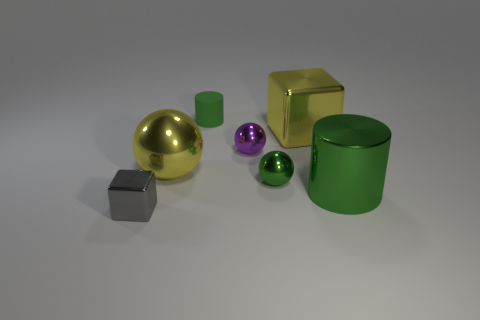Add 1 yellow cubes. How many objects exist? 8 Subtract all cylinders. How many objects are left? 5 Subtract all brown spheres. Subtract all matte things. How many objects are left? 6 Add 1 big balls. How many big balls are left? 2 Add 4 big yellow objects. How many big yellow objects exist? 6 Subtract 1 green balls. How many objects are left? 6 